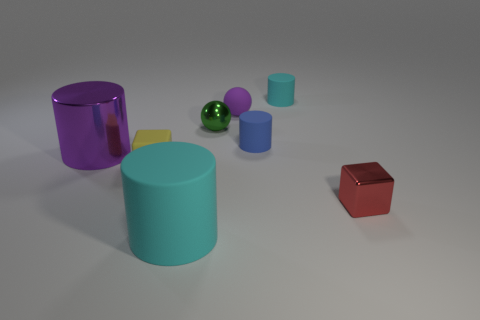Does the tiny matte ball have the same color as the large metallic cylinder?
Give a very brief answer. Yes. Is the cyan cylinder in front of the purple metallic object made of the same material as the purple object to the left of the purple rubber sphere?
Provide a succinct answer. No. Are there more purple shiny cylinders than tiny green matte balls?
Your answer should be very brief. Yes. Is there any other thing that is the same color as the small metal ball?
Keep it short and to the point. No. Do the large purple thing and the green sphere have the same material?
Make the answer very short. Yes. Are there fewer purple rubber things than green rubber cubes?
Provide a succinct answer. No. Is the small green object the same shape as the tiny cyan matte object?
Your response must be concise. No. What color is the rubber ball?
Offer a very short reply. Purple. What number of other objects are there of the same material as the tiny red object?
Keep it short and to the point. 2. What number of green things are either cylinders or shiny objects?
Offer a very short reply. 1. 